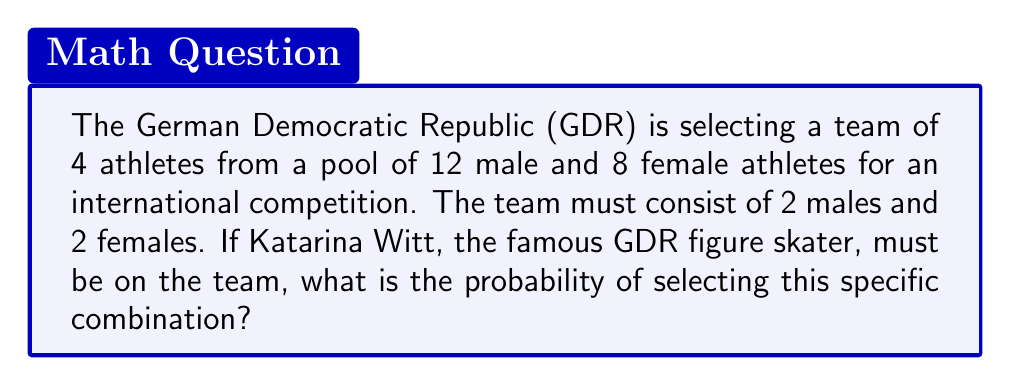What is the answer to this math problem? Let's approach this step-by-step:

1) Katarina Witt must be on the team, so we only need to select 1 more female athlete out of the remaining 7.

2) We need to select 2 male athletes out of 12.

3) For the female selection:
   - We have 7 choices for 1 position
   - This can be calculated using the combination formula: $\binom{7}{1} = 7$

4) For the male selection:
   - We have 12 choices for 2 positions
   - This can be calculated using the combination formula: $\binom{12}{2} = 66$

5) By the multiplication principle, the total number of ways to select this team is:
   $7 \times 66 = 462$

6) To find the probability, we need to divide this by the total number of possible teams:
   - Total teams = $\binom{8}{2} \times \binom{12}{2} = 28 \times 66 = 1,848$

7) Therefore, the probability is:
   $\frac{462}{1,848} = \frac{1}{4} = 0.25$
Answer: $\frac{1}{4}$ or $0.25$ or $25\%$ 